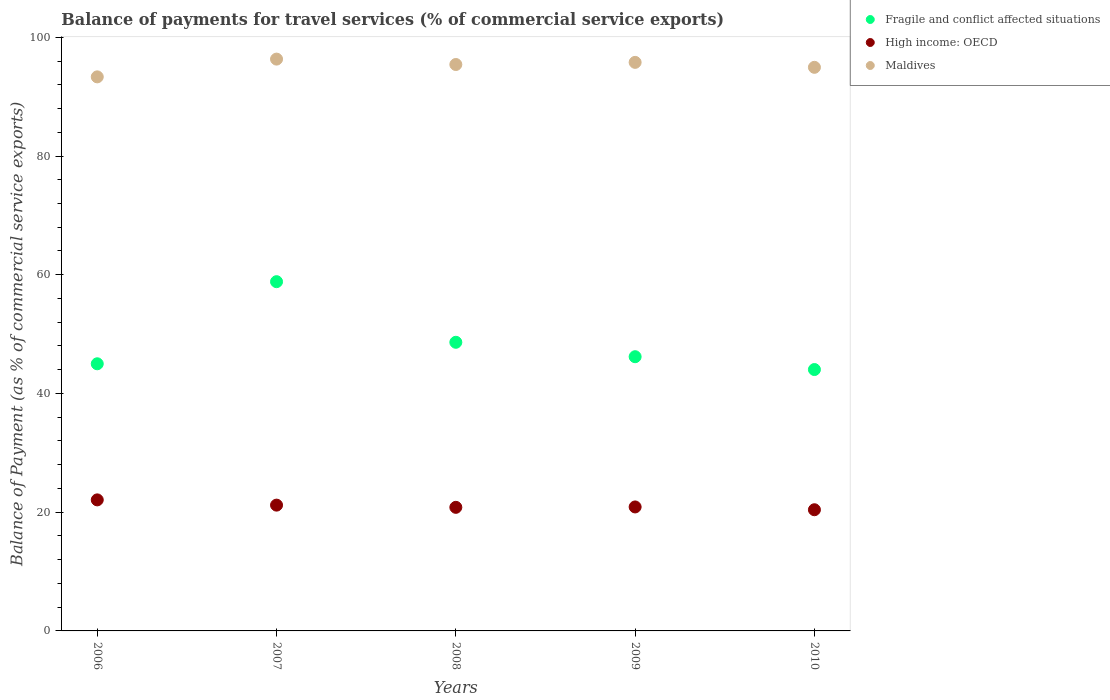What is the balance of payments for travel services in Fragile and conflict affected situations in 2006?
Your answer should be compact. 45. Across all years, what is the maximum balance of payments for travel services in Fragile and conflict affected situations?
Give a very brief answer. 58.83. Across all years, what is the minimum balance of payments for travel services in Maldives?
Ensure brevity in your answer.  93.33. In which year was the balance of payments for travel services in Fragile and conflict affected situations minimum?
Your answer should be very brief. 2010. What is the total balance of payments for travel services in Fragile and conflict affected situations in the graph?
Provide a short and direct response. 242.67. What is the difference between the balance of payments for travel services in Maldives in 2006 and that in 2007?
Your response must be concise. -2.99. What is the difference between the balance of payments for travel services in Maldives in 2010 and the balance of payments for travel services in High income: OECD in 2007?
Offer a very short reply. 73.75. What is the average balance of payments for travel services in High income: OECD per year?
Provide a short and direct response. 21.08. In the year 2006, what is the difference between the balance of payments for travel services in Fragile and conflict affected situations and balance of payments for travel services in High income: OECD?
Your answer should be very brief. 22.93. What is the ratio of the balance of payments for travel services in Fragile and conflict affected situations in 2006 to that in 2007?
Your answer should be very brief. 0.76. Is the balance of payments for travel services in Fragile and conflict affected situations in 2006 less than that in 2010?
Keep it short and to the point. No. What is the difference between the highest and the second highest balance of payments for travel services in High income: OECD?
Ensure brevity in your answer.  0.88. What is the difference between the highest and the lowest balance of payments for travel services in Fragile and conflict affected situations?
Offer a very short reply. 14.8. Is the sum of the balance of payments for travel services in Maldives in 2008 and 2010 greater than the maximum balance of payments for travel services in High income: OECD across all years?
Your answer should be compact. Yes. How many years are there in the graph?
Your answer should be very brief. 5. Does the graph contain any zero values?
Offer a terse response. No. What is the title of the graph?
Your response must be concise. Balance of payments for travel services (% of commercial service exports). What is the label or title of the X-axis?
Provide a short and direct response. Years. What is the label or title of the Y-axis?
Your response must be concise. Balance of Payment (as % of commercial service exports). What is the Balance of Payment (as % of commercial service exports) of Fragile and conflict affected situations in 2006?
Offer a very short reply. 45. What is the Balance of Payment (as % of commercial service exports) of High income: OECD in 2006?
Your answer should be compact. 22.07. What is the Balance of Payment (as % of commercial service exports) in Maldives in 2006?
Keep it short and to the point. 93.33. What is the Balance of Payment (as % of commercial service exports) in Fragile and conflict affected situations in 2007?
Keep it short and to the point. 58.83. What is the Balance of Payment (as % of commercial service exports) of High income: OECD in 2007?
Your answer should be compact. 21.19. What is the Balance of Payment (as % of commercial service exports) in Maldives in 2007?
Offer a very short reply. 96.32. What is the Balance of Payment (as % of commercial service exports) of Fragile and conflict affected situations in 2008?
Your response must be concise. 48.62. What is the Balance of Payment (as % of commercial service exports) in High income: OECD in 2008?
Offer a very short reply. 20.82. What is the Balance of Payment (as % of commercial service exports) in Maldives in 2008?
Provide a succinct answer. 95.41. What is the Balance of Payment (as % of commercial service exports) of Fragile and conflict affected situations in 2009?
Offer a terse response. 46.19. What is the Balance of Payment (as % of commercial service exports) in High income: OECD in 2009?
Ensure brevity in your answer.  20.88. What is the Balance of Payment (as % of commercial service exports) in Maldives in 2009?
Your answer should be very brief. 95.77. What is the Balance of Payment (as % of commercial service exports) in Fragile and conflict affected situations in 2010?
Give a very brief answer. 44.03. What is the Balance of Payment (as % of commercial service exports) in High income: OECD in 2010?
Make the answer very short. 20.41. What is the Balance of Payment (as % of commercial service exports) in Maldives in 2010?
Ensure brevity in your answer.  94.94. Across all years, what is the maximum Balance of Payment (as % of commercial service exports) of Fragile and conflict affected situations?
Give a very brief answer. 58.83. Across all years, what is the maximum Balance of Payment (as % of commercial service exports) of High income: OECD?
Your answer should be compact. 22.07. Across all years, what is the maximum Balance of Payment (as % of commercial service exports) of Maldives?
Provide a short and direct response. 96.32. Across all years, what is the minimum Balance of Payment (as % of commercial service exports) in Fragile and conflict affected situations?
Provide a succinct answer. 44.03. Across all years, what is the minimum Balance of Payment (as % of commercial service exports) of High income: OECD?
Ensure brevity in your answer.  20.41. Across all years, what is the minimum Balance of Payment (as % of commercial service exports) in Maldives?
Your answer should be very brief. 93.33. What is the total Balance of Payment (as % of commercial service exports) of Fragile and conflict affected situations in the graph?
Your answer should be compact. 242.67. What is the total Balance of Payment (as % of commercial service exports) of High income: OECD in the graph?
Make the answer very short. 105.38. What is the total Balance of Payment (as % of commercial service exports) of Maldives in the graph?
Provide a short and direct response. 475.78. What is the difference between the Balance of Payment (as % of commercial service exports) of Fragile and conflict affected situations in 2006 and that in 2007?
Provide a short and direct response. -13.83. What is the difference between the Balance of Payment (as % of commercial service exports) in High income: OECD in 2006 and that in 2007?
Your response must be concise. 0.88. What is the difference between the Balance of Payment (as % of commercial service exports) in Maldives in 2006 and that in 2007?
Your response must be concise. -2.99. What is the difference between the Balance of Payment (as % of commercial service exports) of Fragile and conflict affected situations in 2006 and that in 2008?
Provide a succinct answer. -3.62. What is the difference between the Balance of Payment (as % of commercial service exports) of High income: OECD in 2006 and that in 2008?
Provide a succinct answer. 1.26. What is the difference between the Balance of Payment (as % of commercial service exports) of Maldives in 2006 and that in 2008?
Make the answer very short. -2.08. What is the difference between the Balance of Payment (as % of commercial service exports) in Fragile and conflict affected situations in 2006 and that in 2009?
Offer a terse response. -1.19. What is the difference between the Balance of Payment (as % of commercial service exports) in High income: OECD in 2006 and that in 2009?
Ensure brevity in your answer.  1.19. What is the difference between the Balance of Payment (as % of commercial service exports) of Maldives in 2006 and that in 2009?
Your answer should be compact. -2.44. What is the difference between the Balance of Payment (as % of commercial service exports) of High income: OECD in 2006 and that in 2010?
Make the answer very short. 1.66. What is the difference between the Balance of Payment (as % of commercial service exports) in Maldives in 2006 and that in 2010?
Provide a short and direct response. -1.61. What is the difference between the Balance of Payment (as % of commercial service exports) in Fragile and conflict affected situations in 2007 and that in 2008?
Your answer should be very brief. 10.21. What is the difference between the Balance of Payment (as % of commercial service exports) in High income: OECD in 2007 and that in 2008?
Your answer should be compact. 0.37. What is the difference between the Balance of Payment (as % of commercial service exports) in Fragile and conflict affected situations in 2007 and that in 2009?
Offer a terse response. 12.64. What is the difference between the Balance of Payment (as % of commercial service exports) of High income: OECD in 2007 and that in 2009?
Make the answer very short. 0.31. What is the difference between the Balance of Payment (as % of commercial service exports) of Maldives in 2007 and that in 2009?
Offer a very short reply. 0.55. What is the difference between the Balance of Payment (as % of commercial service exports) of Fragile and conflict affected situations in 2007 and that in 2010?
Offer a very short reply. 14.8. What is the difference between the Balance of Payment (as % of commercial service exports) of High income: OECD in 2007 and that in 2010?
Provide a succinct answer. 0.78. What is the difference between the Balance of Payment (as % of commercial service exports) in Maldives in 2007 and that in 2010?
Provide a short and direct response. 1.38. What is the difference between the Balance of Payment (as % of commercial service exports) of Fragile and conflict affected situations in 2008 and that in 2009?
Make the answer very short. 2.43. What is the difference between the Balance of Payment (as % of commercial service exports) in High income: OECD in 2008 and that in 2009?
Provide a short and direct response. -0.07. What is the difference between the Balance of Payment (as % of commercial service exports) in Maldives in 2008 and that in 2009?
Your answer should be compact. -0.36. What is the difference between the Balance of Payment (as % of commercial service exports) in Fragile and conflict affected situations in 2008 and that in 2010?
Offer a terse response. 4.59. What is the difference between the Balance of Payment (as % of commercial service exports) in High income: OECD in 2008 and that in 2010?
Your answer should be compact. 0.41. What is the difference between the Balance of Payment (as % of commercial service exports) in Maldives in 2008 and that in 2010?
Make the answer very short. 0.48. What is the difference between the Balance of Payment (as % of commercial service exports) in Fragile and conflict affected situations in 2009 and that in 2010?
Keep it short and to the point. 2.16. What is the difference between the Balance of Payment (as % of commercial service exports) of High income: OECD in 2009 and that in 2010?
Ensure brevity in your answer.  0.47. What is the difference between the Balance of Payment (as % of commercial service exports) of Maldives in 2009 and that in 2010?
Offer a very short reply. 0.83. What is the difference between the Balance of Payment (as % of commercial service exports) of Fragile and conflict affected situations in 2006 and the Balance of Payment (as % of commercial service exports) of High income: OECD in 2007?
Keep it short and to the point. 23.81. What is the difference between the Balance of Payment (as % of commercial service exports) in Fragile and conflict affected situations in 2006 and the Balance of Payment (as % of commercial service exports) in Maldives in 2007?
Provide a short and direct response. -51.32. What is the difference between the Balance of Payment (as % of commercial service exports) in High income: OECD in 2006 and the Balance of Payment (as % of commercial service exports) in Maldives in 2007?
Offer a terse response. -74.25. What is the difference between the Balance of Payment (as % of commercial service exports) of Fragile and conflict affected situations in 2006 and the Balance of Payment (as % of commercial service exports) of High income: OECD in 2008?
Your answer should be very brief. 24.18. What is the difference between the Balance of Payment (as % of commercial service exports) of Fragile and conflict affected situations in 2006 and the Balance of Payment (as % of commercial service exports) of Maldives in 2008?
Offer a very short reply. -50.41. What is the difference between the Balance of Payment (as % of commercial service exports) of High income: OECD in 2006 and the Balance of Payment (as % of commercial service exports) of Maldives in 2008?
Your response must be concise. -73.34. What is the difference between the Balance of Payment (as % of commercial service exports) of Fragile and conflict affected situations in 2006 and the Balance of Payment (as % of commercial service exports) of High income: OECD in 2009?
Your response must be concise. 24.12. What is the difference between the Balance of Payment (as % of commercial service exports) of Fragile and conflict affected situations in 2006 and the Balance of Payment (as % of commercial service exports) of Maldives in 2009?
Offer a terse response. -50.77. What is the difference between the Balance of Payment (as % of commercial service exports) of High income: OECD in 2006 and the Balance of Payment (as % of commercial service exports) of Maldives in 2009?
Your response must be concise. -73.7. What is the difference between the Balance of Payment (as % of commercial service exports) in Fragile and conflict affected situations in 2006 and the Balance of Payment (as % of commercial service exports) in High income: OECD in 2010?
Your answer should be compact. 24.59. What is the difference between the Balance of Payment (as % of commercial service exports) of Fragile and conflict affected situations in 2006 and the Balance of Payment (as % of commercial service exports) of Maldives in 2010?
Offer a very short reply. -49.94. What is the difference between the Balance of Payment (as % of commercial service exports) of High income: OECD in 2006 and the Balance of Payment (as % of commercial service exports) of Maldives in 2010?
Ensure brevity in your answer.  -72.86. What is the difference between the Balance of Payment (as % of commercial service exports) of Fragile and conflict affected situations in 2007 and the Balance of Payment (as % of commercial service exports) of High income: OECD in 2008?
Offer a terse response. 38.01. What is the difference between the Balance of Payment (as % of commercial service exports) in Fragile and conflict affected situations in 2007 and the Balance of Payment (as % of commercial service exports) in Maldives in 2008?
Provide a short and direct response. -36.58. What is the difference between the Balance of Payment (as % of commercial service exports) in High income: OECD in 2007 and the Balance of Payment (as % of commercial service exports) in Maldives in 2008?
Provide a succinct answer. -74.22. What is the difference between the Balance of Payment (as % of commercial service exports) of Fragile and conflict affected situations in 2007 and the Balance of Payment (as % of commercial service exports) of High income: OECD in 2009?
Offer a terse response. 37.95. What is the difference between the Balance of Payment (as % of commercial service exports) in Fragile and conflict affected situations in 2007 and the Balance of Payment (as % of commercial service exports) in Maldives in 2009?
Ensure brevity in your answer.  -36.94. What is the difference between the Balance of Payment (as % of commercial service exports) of High income: OECD in 2007 and the Balance of Payment (as % of commercial service exports) of Maldives in 2009?
Ensure brevity in your answer.  -74.58. What is the difference between the Balance of Payment (as % of commercial service exports) of Fragile and conflict affected situations in 2007 and the Balance of Payment (as % of commercial service exports) of High income: OECD in 2010?
Offer a very short reply. 38.42. What is the difference between the Balance of Payment (as % of commercial service exports) in Fragile and conflict affected situations in 2007 and the Balance of Payment (as % of commercial service exports) in Maldives in 2010?
Your answer should be compact. -36.11. What is the difference between the Balance of Payment (as % of commercial service exports) of High income: OECD in 2007 and the Balance of Payment (as % of commercial service exports) of Maldives in 2010?
Offer a very short reply. -73.75. What is the difference between the Balance of Payment (as % of commercial service exports) in Fragile and conflict affected situations in 2008 and the Balance of Payment (as % of commercial service exports) in High income: OECD in 2009?
Give a very brief answer. 27.74. What is the difference between the Balance of Payment (as % of commercial service exports) of Fragile and conflict affected situations in 2008 and the Balance of Payment (as % of commercial service exports) of Maldives in 2009?
Offer a terse response. -47.15. What is the difference between the Balance of Payment (as % of commercial service exports) in High income: OECD in 2008 and the Balance of Payment (as % of commercial service exports) in Maldives in 2009?
Provide a short and direct response. -74.95. What is the difference between the Balance of Payment (as % of commercial service exports) in Fragile and conflict affected situations in 2008 and the Balance of Payment (as % of commercial service exports) in High income: OECD in 2010?
Offer a very short reply. 28.21. What is the difference between the Balance of Payment (as % of commercial service exports) in Fragile and conflict affected situations in 2008 and the Balance of Payment (as % of commercial service exports) in Maldives in 2010?
Your answer should be compact. -46.32. What is the difference between the Balance of Payment (as % of commercial service exports) in High income: OECD in 2008 and the Balance of Payment (as % of commercial service exports) in Maldives in 2010?
Make the answer very short. -74.12. What is the difference between the Balance of Payment (as % of commercial service exports) of Fragile and conflict affected situations in 2009 and the Balance of Payment (as % of commercial service exports) of High income: OECD in 2010?
Provide a short and direct response. 25.78. What is the difference between the Balance of Payment (as % of commercial service exports) of Fragile and conflict affected situations in 2009 and the Balance of Payment (as % of commercial service exports) of Maldives in 2010?
Offer a very short reply. -48.75. What is the difference between the Balance of Payment (as % of commercial service exports) of High income: OECD in 2009 and the Balance of Payment (as % of commercial service exports) of Maldives in 2010?
Give a very brief answer. -74.05. What is the average Balance of Payment (as % of commercial service exports) in Fragile and conflict affected situations per year?
Your answer should be very brief. 48.53. What is the average Balance of Payment (as % of commercial service exports) of High income: OECD per year?
Give a very brief answer. 21.08. What is the average Balance of Payment (as % of commercial service exports) in Maldives per year?
Provide a short and direct response. 95.16. In the year 2006, what is the difference between the Balance of Payment (as % of commercial service exports) in Fragile and conflict affected situations and Balance of Payment (as % of commercial service exports) in High income: OECD?
Your answer should be compact. 22.93. In the year 2006, what is the difference between the Balance of Payment (as % of commercial service exports) of Fragile and conflict affected situations and Balance of Payment (as % of commercial service exports) of Maldives?
Your response must be concise. -48.33. In the year 2006, what is the difference between the Balance of Payment (as % of commercial service exports) in High income: OECD and Balance of Payment (as % of commercial service exports) in Maldives?
Your response must be concise. -71.26. In the year 2007, what is the difference between the Balance of Payment (as % of commercial service exports) of Fragile and conflict affected situations and Balance of Payment (as % of commercial service exports) of High income: OECD?
Your answer should be very brief. 37.64. In the year 2007, what is the difference between the Balance of Payment (as % of commercial service exports) in Fragile and conflict affected situations and Balance of Payment (as % of commercial service exports) in Maldives?
Offer a very short reply. -37.49. In the year 2007, what is the difference between the Balance of Payment (as % of commercial service exports) in High income: OECD and Balance of Payment (as % of commercial service exports) in Maldives?
Provide a succinct answer. -75.13. In the year 2008, what is the difference between the Balance of Payment (as % of commercial service exports) of Fragile and conflict affected situations and Balance of Payment (as % of commercial service exports) of High income: OECD?
Keep it short and to the point. 27.8. In the year 2008, what is the difference between the Balance of Payment (as % of commercial service exports) in Fragile and conflict affected situations and Balance of Payment (as % of commercial service exports) in Maldives?
Provide a succinct answer. -46.79. In the year 2008, what is the difference between the Balance of Payment (as % of commercial service exports) of High income: OECD and Balance of Payment (as % of commercial service exports) of Maldives?
Make the answer very short. -74.6. In the year 2009, what is the difference between the Balance of Payment (as % of commercial service exports) in Fragile and conflict affected situations and Balance of Payment (as % of commercial service exports) in High income: OECD?
Your response must be concise. 25.31. In the year 2009, what is the difference between the Balance of Payment (as % of commercial service exports) of Fragile and conflict affected situations and Balance of Payment (as % of commercial service exports) of Maldives?
Offer a very short reply. -49.58. In the year 2009, what is the difference between the Balance of Payment (as % of commercial service exports) in High income: OECD and Balance of Payment (as % of commercial service exports) in Maldives?
Your answer should be compact. -74.89. In the year 2010, what is the difference between the Balance of Payment (as % of commercial service exports) of Fragile and conflict affected situations and Balance of Payment (as % of commercial service exports) of High income: OECD?
Keep it short and to the point. 23.62. In the year 2010, what is the difference between the Balance of Payment (as % of commercial service exports) of Fragile and conflict affected situations and Balance of Payment (as % of commercial service exports) of Maldives?
Your response must be concise. -50.91. In the year 2010, what is the difference between the Balance of Payment (as % of commercial service exports) of High income: OECD and Balance of Payment (as % of commercial service exports) of Maldives?
Give a very brief answer. -74.53. What is the ratio of the Balance of Payment (as % of commercial service exports) of Fragile and conflict affected situations in 2006 to that in 2007?
Make the answer very short. 0.76. What is the ratio of the Balance of Payment (as % of commercial service exports) in High income: OECD in 2006 to that in 2007?
Your answer should be very brief. 1.04. What is the ratio of the Balance of Payment (as % of commercial service exports) of Maldives in 2006 to that in 2007?
Make the answer very short. 0.97. What is the ratio of the Balance of Payment (as % of commercial service exports) of Fragile and conflict affected situations in 2006 to that in 2008?
Make the answer very short. 0.93. What is the ratio of the Balance of Payment (as % of commercial service exports) of High income: OECD in 2006 to that in 2008?
Keep it short and to the point. 1.06. What is the ratio of the Balance of Payment (as % of commercial service exports) in Maldives in 2006 to that in 2008?
Provide a succinct answer. 0.98. What is the ratio of the Balance of Payment (as % of commercial service exports) of Fragile and conflict affected situations in 2006 to that in 2009?
Provide a succinct answer. 0.97. What is the ratio of the Balance of Payment (as % of commercial service exports) of High income: OECD in 2006 to that in 2009?
Your answer should be compact. 1.06. What is the ratio of the Balance of Payment (as % of commercial service exports) in Maldives in 2006 to that in 2009?
Provide a short and direct response. 0.97. What is the ratio of the Balance of Payment (as % of commercial service exports) of High income: OECD in 2006 to that in 2010?
Your response must be concise. 1.08. What is the ratio of the Balance of Payment (as % of commercial service exports) of Maldives in 2006 to that in 2010?
Your answer should be very brief. 0.98. What is the ratio of the Balance of Payment (as % of commercial service exports) in Fragile and conflict affected situations in 2007 to that in 2008?
Offer a terse response. 1.21. What is the ratio of the Balance of Payment (as % of commercial service exports) in High income: OECD in 2007 to that in 2008?
Offer a very short reply. 1.02. What is the ratio of the Balance of Payment (as % of commercial service exports) in Maldives in 2007 to that in 2008?
Make the answer very short. 1.01. What is the ratio of the Balance of Payment (as % of commercial service exports) of Fragile and conflict affected situations in 2007 to that in 2009?
Your answer should be very brief. 1.27. What is the ratio of the Balance of Payment (as % of commercial service exports) in High income: OECD in 2007 to that in 2009?
Give a very brief answer. 1.01. What is the ratio of the Balance of Payment (as % of commercial service exports) of Maldives in 2007 to that in 2009?
Provide a succinct answer. 1.01. What is the ratio of the Balance of Payment (as % of commercial service exports) of Fragile and conflict affected situations in 2007 to that in 2010?
Your answer should be very brief. 1.34. What is the ratio of the Balance of Payment (as % of commercial service exports) of High income: OECD in 2007 to that in 2010?
Ensure brevity in your answer.  1.04. What is the ratio of the Balance of Payment (as % of commercial service exports) in Maldives in 2007 to that in 2010?
Provide a succinct answer. 1.01. What is the ratio of the Balance of Payment (as % of commercial service exports) of Fragile and conflict affected situations in 2008 to that in 2009?
Make the answer very short. 1.05. What is the ratio of the Balance of Payment (as % of commercial service exports) of Maldives in 2008 to that in 2009?
Provide a short and direct response. 1. What is the ratio of the Balance of Payment (as % of commercial service exports) of Fragile and conflict affected situations in 2008 to that in 2010?
Provide a short and direct response. 1.1. What is the ratio of the Balance of Payment (as % of commercial service exports) in High income: OECD in 2008 to that in 2010?
Your answer should be compact. 1.02. What is the ratio of the Balance of Payment (as % of commercial service exports) in Maldives in 2008 to that in 2010?
Your answer should be very brief. 1. What is the ratio of the Balance of Payment (as % of commercial service exports) of Fragile and conflict affected situations in 2009 to that in 2010?
Give a very brief answer. 1.05. What is the ratio of the Balance of Payment (as % of commercial service exports) in High income: OECD in 2009 to that in 2010?
Offer a very short reply. 1.02. What is the ratio of the Balance of Payment (as % of commercial service exports) in Maldives in 2009 to that in 2010?
Offer a terse response. 1.01. What is the difference between the highest and the second highest Balance of Payment (as % of commercial service exports) of Fragile and conflict affected situations?
Keep it short and to the point. 10.21. What is the difference between the highest and the second highest Balance of Payment (as % of commercial service exports) of High income: OECD?
Ensure brevity in your answer.  0.88. What is the difference between the highest and the second highest Balance of Payment (as % of commercial service exports) of Maldives?
Ensure brevity in your answer.  0.55. What is the difference between the highest and the lowest Balance of Payment (as % of commercial service exports) of Fragile and conflict affected situations?
Keep it short and to the point. 14.8. What is the difference between the highest and the lowest Balance of Payment (as % of commercial service exports) of High income: OECD?
Your answer should be very brief. 1.66. What is the difference between the highest and the lowest Balance of Payment (as % of commercial service exports) in Maldives?
Your response must be concise. 2.99. 